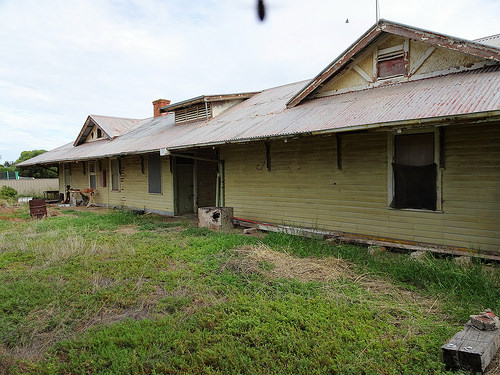<image>
Can you confirm if the window is on the grass? No. The window is not positioned on the grass. They may be near each other, but the window is not supported by or resting on top of the grass. 